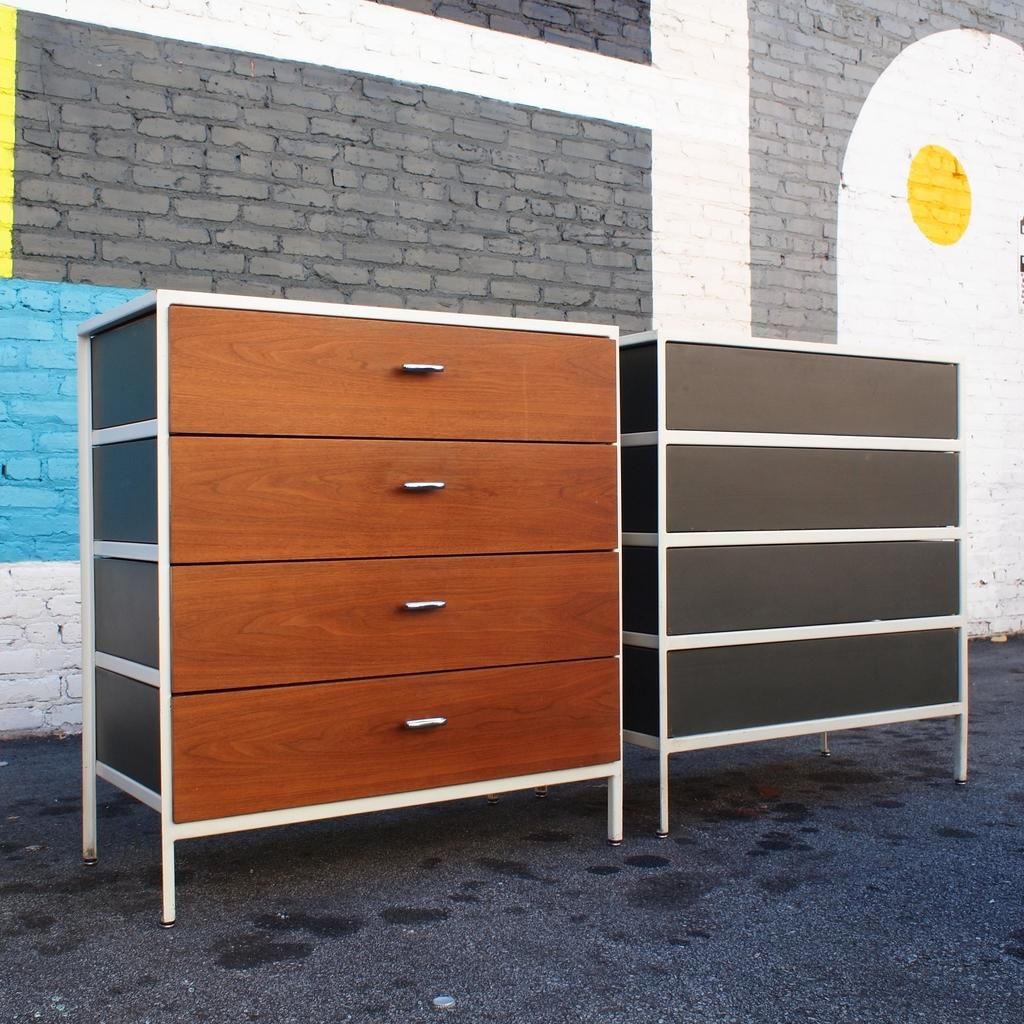What type of furniture can be seen in the front of the image? There are cupboards in the front of the image. What is visible in the background of the image? There is a wall in the background of the image. What decorative item is on the wall? There is a painting on the wall. What type of stocking is hanging from the painting in the image? There is no stocking hanging from the painting in the image. 